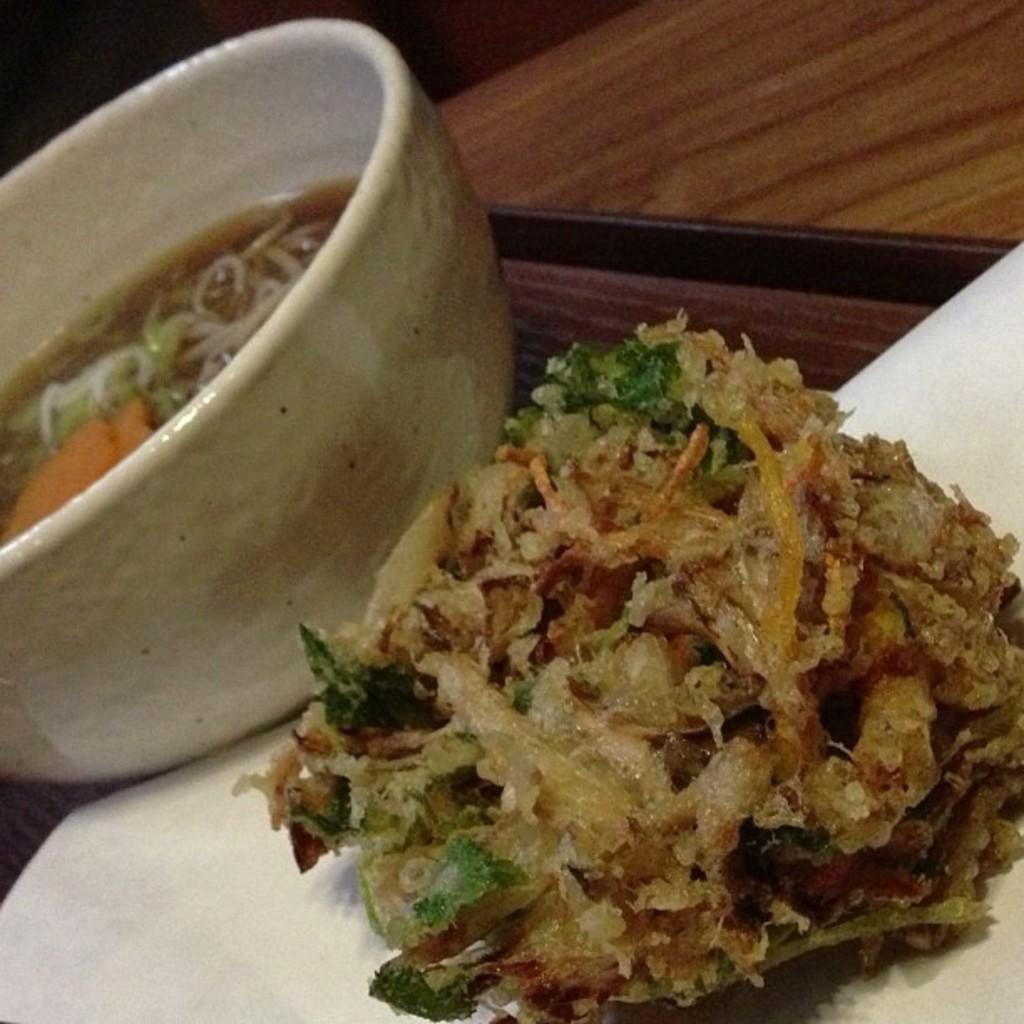What is the main dish in the image? There is a bowl of soup in the center of the image. What other food item can be seen in the image? There is food in a plate in the image. Where are the bowl and plate located? Both the bowl and plate are placed on a table. How many kittens are sitting on the bread in the image? There is no bread or kittens present in the image. 